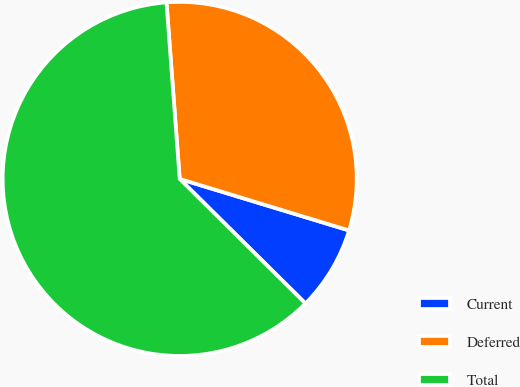<chart> <loc_0><loc_0><loc_500><loc_500><pie_chart><fcel>Current<fcel>Deferred<fcel>Total<nl><fcel>7.72%<fcel>30.89%<fcel>61.39%<nl></chart> 